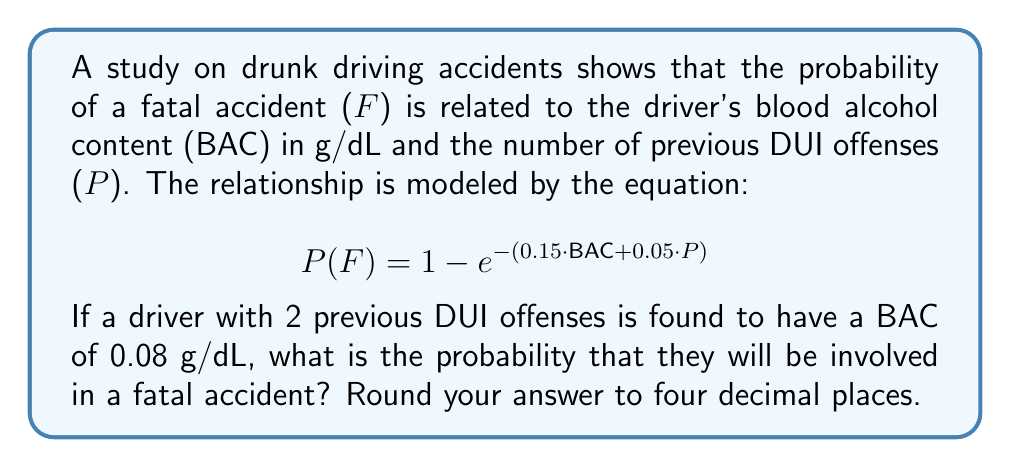Could you help me with this problem? To solve this problem, we need to follow these steps:

1. Identify the given values:
   - Blood Alcohol Content (BAC) = 0.08 g/dL
   - Number of previous DUI offenses (P) = 2

2. Substitute these values into the equation:
   $$P(F) = 1 - e^{-(0.15 \cdot BAC + 0.05 \cdot P)}$$
   $$P(F) = 1 - e^{-(0.15 \cdot 0.08 + 0.05 \cdot 2)}$$

3. Calculate the exponent:
   $$0.15 \cdot 0.08 = 0.012$$
   $$0.05 \cdot 2 = 0.1$$
   $$0.012 + 0.1 = 0.112$$

4. Simplify the equation:
   $$P(F) = 1 - e^{-0.112}$$

5. Calculate $e^{-0.112}$ using a calculator:
   $$e^{-0.112} \approx 0.8941$$

6. Subtract from 1:
   $$P(F) = 1 - 0.8941 = 0.1059$$

7. Round to four decimal places:
   $$P(F) \approx 0.1059$$

Therefore, the probability of a fatal accident for this driver is approximately 0.1059 or 10.59%.
Answer: 0.1059 